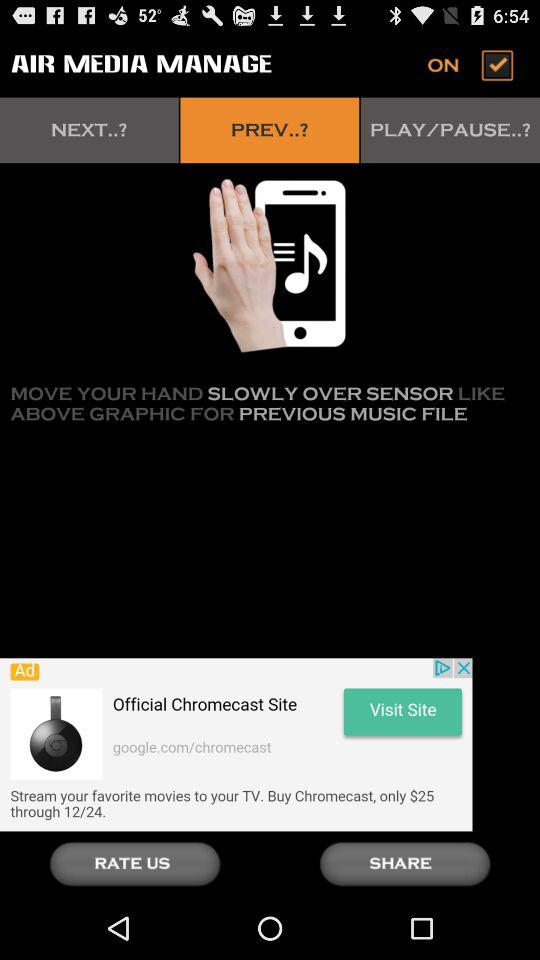What is the selected option? The selected option is "PREV..?". 